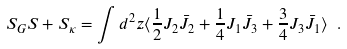Convert formula to latex. <formula><loc_0><loc_0><loc_500><loc_500>S _ { G } S + S _ { \kappa } = \int d ^ { 2 } z \langle \frac { 1 } { 2 } J _ { 2 } \bar { J } _ { 2 } + \frac { 1 } { 4 } J _ { 1 } \bar { J } _ { 3 } + \frac { 3 } { 4 } J _ { 3 } \bar { J } _ { 1 } \rangle \ .</formula> 